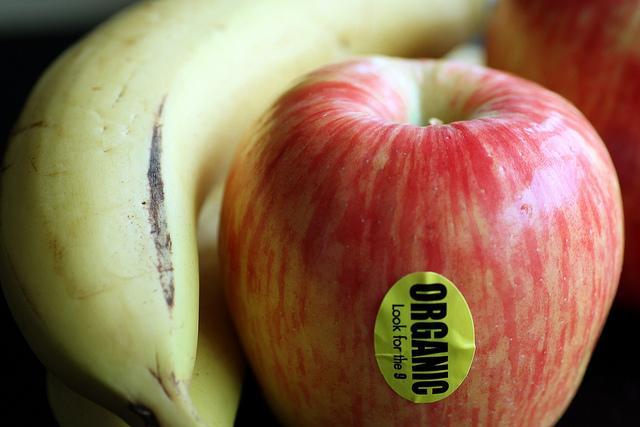Are these organic fruits?
Be succinct. Yes. What are featured?
Give a very brief answer. Banana and apple. What does the sticker say?
Answer briefly. Organic. 